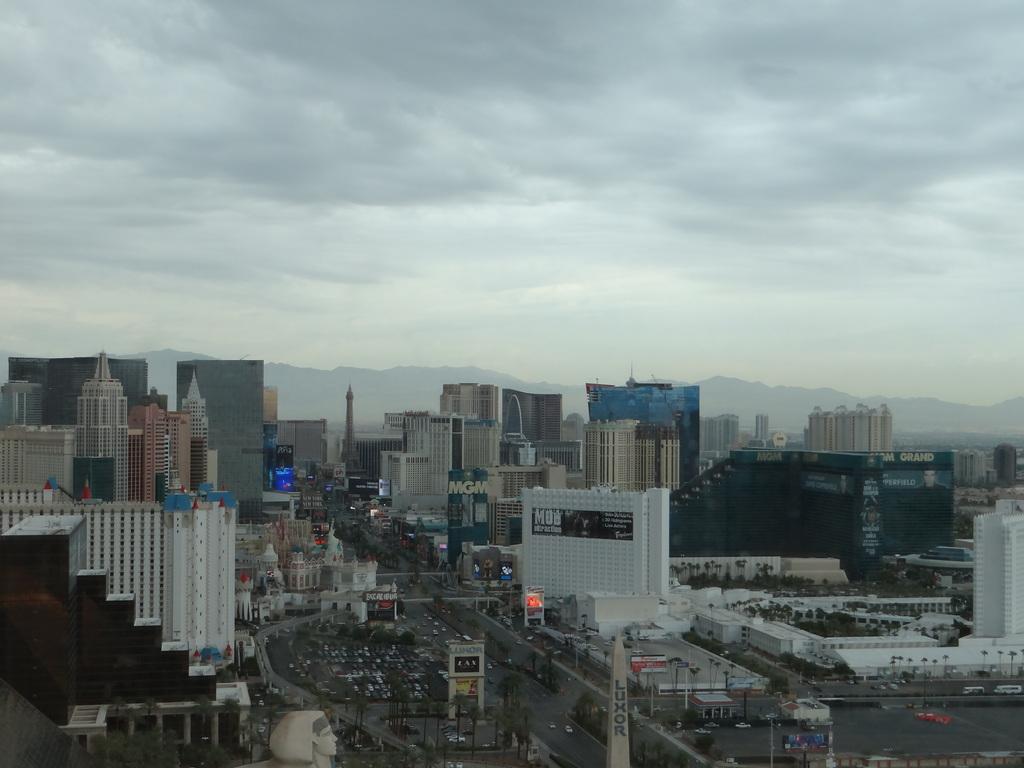Please provide a concise description of this image. There are many buildings, road, trees. On the buildings there some name boards. In the background there are trees and sky. 